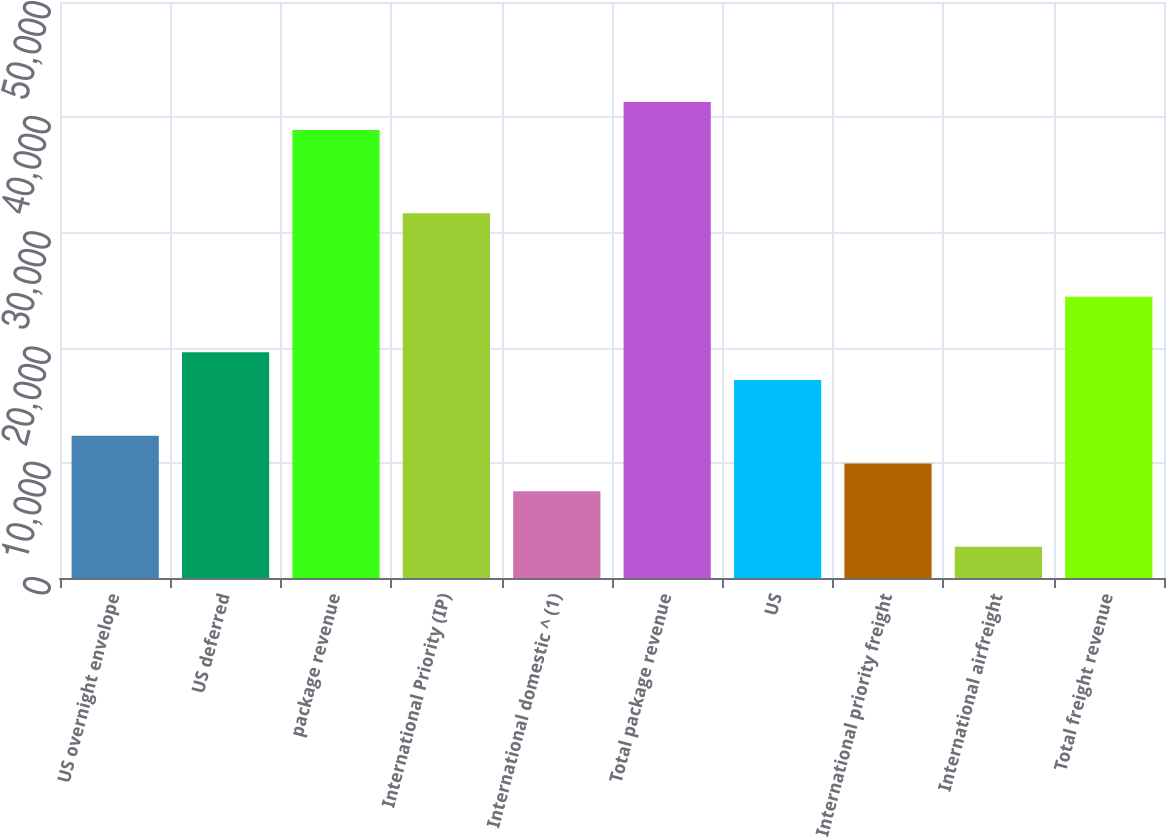Convert chart. <chart><loc_0><loc_0><loc_500><loc_500><bar_chart><fcel>US overnight envelope<fcel>US deferred<fcel>package revenue<fcel>International Priority (IP)<fcel>International domestic ^ (1)<fcel>Total package revenue<fcel>US<fcel>International priority freight<fcel>International airfreight<fcel>Total freight revenue<nl><fcel>12356<fcel>19595<fcel>38899<fcel>31660<fcel>7530<fcel>41312<fcel>17182<fcel>9943<fcel>2704<fcel>24421<nl></chart> 